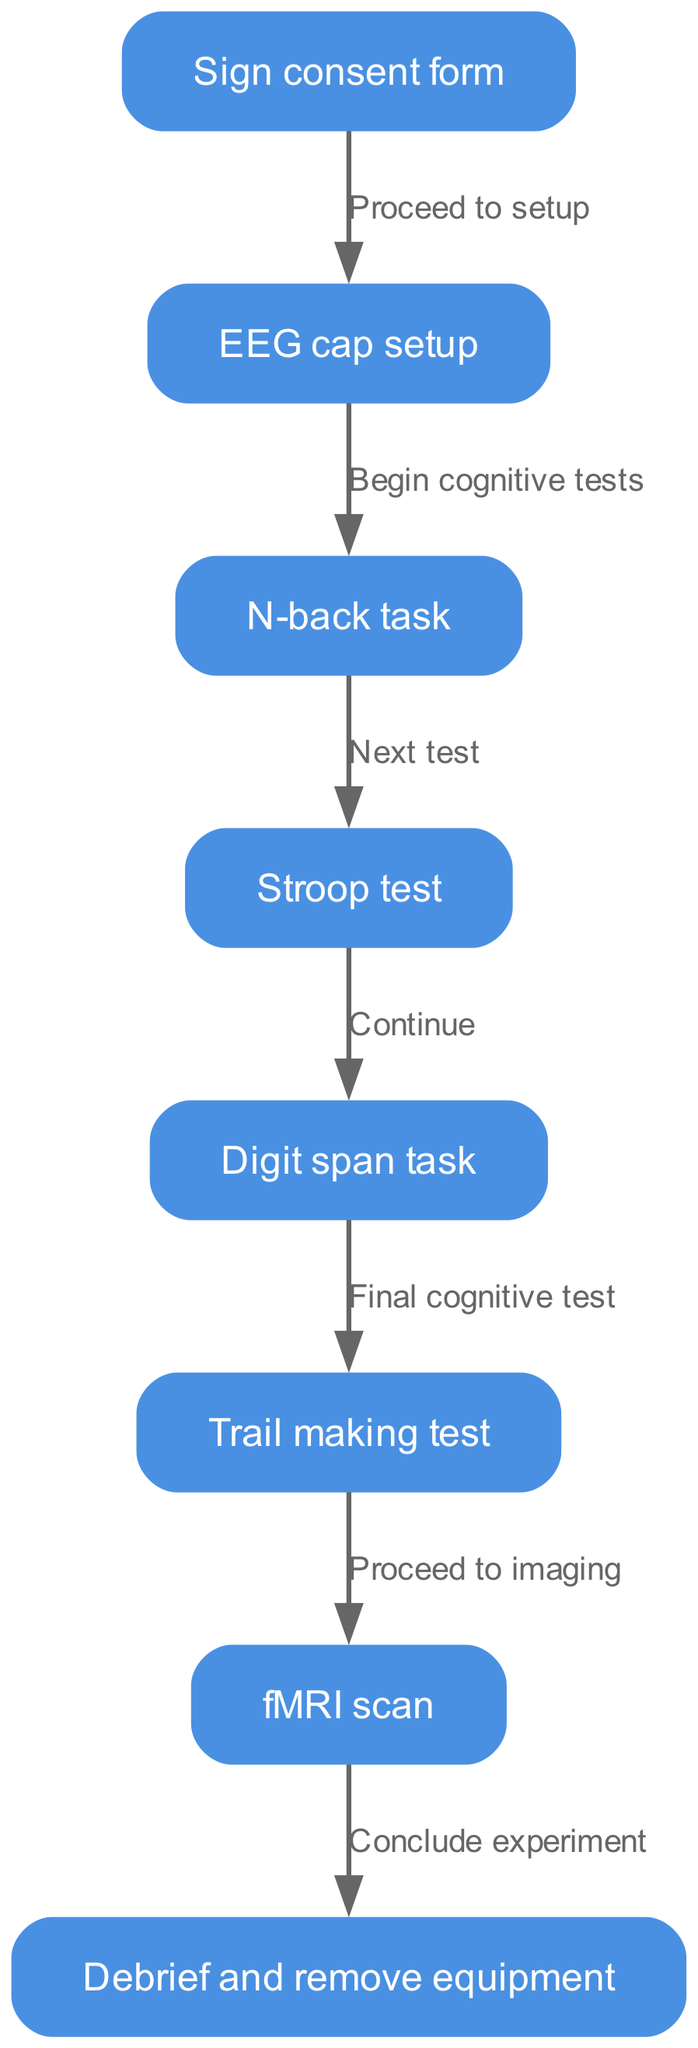What is the first step in the cognitive test sequence? The first step is represented by the node labeled "Sign consent form," indicating that signing the consent form initiates the sequence.
Answer: Sign consent form How many cognitive tests are included in the sequence? The sequence features four cognitive tests: N-back task, Stroop test, Digit span task, and Trail making test, giving a total of four tests.
Answer: Four What is the relationship between the N-back task and the Stroop test? The diagram indicates a flow from the N-back task directly to the Stroop test, showing that after completing the N-back task, the participant proceeds to the Stroop test.
Answer: Next test What follows the EEG cap setup? The sequence indicates that after the EEG cap setup, the participant begins cognitive tests, moving on from setup to assessment tasks.
Answer: Begin cognitive tests After the Trail making test, which step is next? The flowchart shows a direct connection from the Trail making test to the fMRI scan, indicating that once the Trail making test is completed, the participant proceeds to the imaging process.
Answer: Proceed to imaging Which test comes last in the cognitive assessment? The last test in the assessment sequence is the Trail making test, according to the order depicted in the diagram, where it is positioned before the imaging step.
Answer: Trail making test How many edges are present in the diagram? The diagram has a total of seven edges, which represent the connections between the steps in the cognitive test sequence.
Answer: Seven What happens after the fMRI scan? Following the fMRI scan, the final step outlined in the diagram is to debrief and remove equipment, indicating the conclusion of the experiment.
Answer: Conclude experiment What is the purpose of the consent form in the sequence? The consent form is the initial step indicating that participants agree to participate in the cognitive tests and imaging procedures, thus starting the research process legally and ethically.
Answer: Consent agreement 